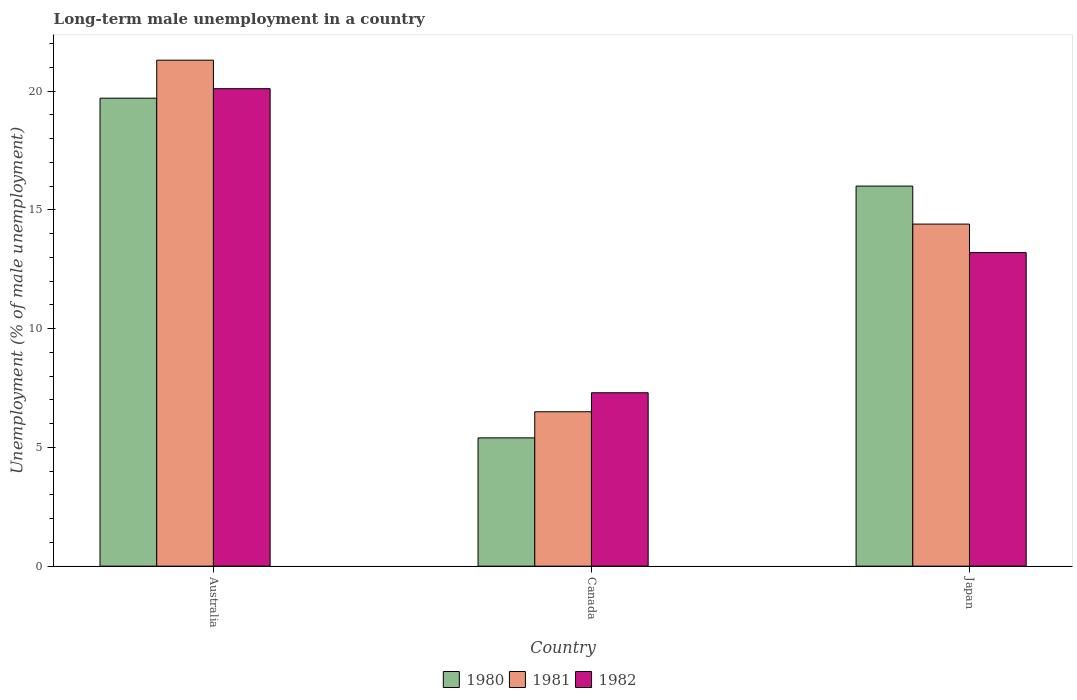How many different coloured bars are there?
Provide a short and direct response. 3. How many groups of bars are there?
Provide a succinct answer. 3. How many bars are there on the 2nd tick from the left?
Offer a very short reply. 3. In how many cases, is the number of bars for a given country not equal to the number of legend labels?
Give a very brief answer. 0. What is the percentage of long-term unemployed male population in 1982 in Canada?
Ensure brevity in your answer.  7.3. Across all countries, what is the maximum percentage of long-term unemployed male population in 1980?
Your response must be concise. 19.7. Across all countries, what is the minimum percentage of long-term unemployed male population in 1982?
Your answer should be compact. 7.3. In which country was the percentage of long-term unemployed male population in 1980 maximum?
Ensure brevity in your answer.  Australia. In which country was the percentage of long-term unemployed male population in 1982 minimum?
Your answer should be very brief. Canada. What is the total percentage of long-term unemployed male population in 1981 in the graph?
Your answer should be very brief. 42.2. What is the difference between the percentage of long-term unemployed male population in 1980 in Australia and that in Japan?
Provide a short and direct response. 3.7. What is the difference between the percentage of long-term unemployed male population in 1982 in Canada and the percentage of long-term unemployed male population in 1981 in Japan?
Give a very brief answer. -7.1. What is the average percentage of long-term unemployed male population in 1981 per country?
Make the answer very short. 14.07. What is the difference between the percentage of long-term unemployed male population of/in 1982 and percentage of long-term unemployed male population of/in 1980 in Australia?
Make the answer very short. 0.4. In how many countries, is the percentage of long-term unemployed male population in 1981 greater than 16 %?
Offer a terse response. 1. What is the ratio of the percentage of long-term unemployed male population in 1982 in Canada to that in Japan?
Offer a terse response. 0.55. Is the percentage of long-term unemployed male population in 1980 in Australia less than that in Japan?
Keep it short and to the point. No. Is the difference between the percentage of long-term unemployed male population in 1982 in Canada and Japan greater than the difference between the percentage of long-term unemployed male population in 1980 in Canada and Japan?
Keep it short and to the point. Yes. What is the difference between the highest and the second highest percentage of long-term unemployed male population in 1980?
Offer a terse response. -3.7. What is the difference between the highest and the lowest percentage of long-term unemployed male population in 1980?
Your answer should be compact. 14.3. In how many countries, is the percentage of long-term unemployed male population in 1980 greater than the average percentage of long-term unemployed male population in 1980 taken over all countries?
Provide a short and direct response. 2. What does the 1st bar from the left in Canada represents?
Your response must be concise. 1980. What is the difference between two consecutive major ticks on the Y-axis?
Offer a terse response. 5. Does the graph contain grids?
Keep it short and to the point. No. Where does the legend appear in the graph?
Offer a terse response. Bottom center. How are the legend labels stacked?
Offer a terse response. Horizontal. What is the title of the graph?
Offer a terse response. Long-term male unemployment in a country. What is the label or title of the X-axis?
Your answer should be compact. Country. What is the label or title of the Y-axis?
Provide a succinct answer. Unemployment (% of male unemployment). What is the Unemployment (% of male unemployment) of 1980 in Australia?
Offer a very short reply. 19.7. What is the Unemployment (% of male unemployment) of 1981 in Australia?
Offer a terse response. 21.3. What is the Unemployment (% of male unemployment) of 1982 in Australia?
Offer a very short reply. 20.1. What is the Unemployment (% of male unemployment) in 1980 in Canada?
Provide a succinct answer. 5.4. What is the Unemployment (% of male unemployment) of 1982 in Canada?
Your response must be concise. 7.3. What is the Unemployment (% of male unemployment) of 1980 in Japan?
Your answer should be very brief. 16. What is the Unemployment (% of male unemployment) of 1981 in Japan?
Your answer should be compact. 14.4. What is the Unemployment (% of male unemployment) in 1982 in Japan?
Make the answer very short. 13.2. Across all countries, what is the maximum Unemployment (% of male unemployment) in 1980?
Provide a succinct answer. 19.7. Across all countries, what is the maximum Unemployment (% of male unemployment) of 1981?
Provide a short and direct response. 21.3. Across all countries, what is the maximum Unemployment (% of male unemployment) in 1982?
Offer a very short reply. 20.1. Across all countries, what is the minimum Unemployment (% of male unemployment) in 1980?
Offer a terse response. 5.4. Across all countries, what is the minimum Unemployment (% of male unemployment) of 1982?
Give a very brief answer. 7.3. What is the total Unemployment (% of male unemployment) of 1980 in the graph?
Offer a terse response. 41.1. What is the total Unemployment (% of male unemployment) of 1981 in the graph?
Offer a very short reply. 42.2. What is the total Unemployment (% of male unemployment) of 1982 in the graph?
Offer a very short reply. 40.6. What is the difference between the Unemployment (% of male unemployment) of 1980 in Australia and that in Canada?
Provide a succinct answer. 14.3. What is the difference between the Unemployment (% of male unemployment) in 1981 in Australia and that in Canada?
Your response must be concise. 14.8. What is the difference between the Unemployment (% of male unemployment) of 1981 in Australia and the Unemployment (% of male unemployment) of 1982 in Canada?
Your answer should be very brief. 14. What is the difference between the Unemployment (% of male unemployment) of 1981 in Australia and the Unemployment (% of male unemployment) of 1982 in Japan?
Provide a succinct answer. 8.1. What is the difference between the Unemployment (% of male unemployment) of 1980 in Canada and the Unemployment (% of male unemployment) of 1982 in Japan?
Ensure brevity in your answer.  -7.8. What is the difference between the Unemployment (% of male unemployment) of 1981 in Canada and the Unemployment (% of male unemployment) of 1982 in Japan?
Your response must be concise. -6.7. What is the average Unemployment (% of male unemployment) in 1981 per country?
Your answer should be compact. 14.07. What is the average Unemployment (% of male unemployment) of 1982 per country?
Ensure brevity in your answer.  13.53. What is the difference between the Unemployment (% of male unemployment) of 1980 and Unemployment (% of male unemployment) of 1982 in Australia?
Offer a very short reply. -0.4. What is the difference between the Unemployment (% of male unemployment) in 1981 and Unemployment (% of male unemployment) in 1982 in Australia?
Provide a succinct answer. 1.2. What is the difference between the Unemployment (% of male unemployment) in 1980 and Unemployment (% of male unemployment) in 1982 in Japan?
Keep it short and to the point. 2.8. What is the difference between the Unemployment (% of male unemployment) in 1981 and Unemployment (% of male unemployment) in 1982 in Japan?
Provide a short and direct response. 1.2. What is the ratio of the Unemployment (% of male unemployment) of 1980 in Australia to that in Canada?
Give a very brief answer. 3.65. What is the ratio of the Unemployment (% of male unemployment) of 1981 in Australia to that in Canada?
Your answer should be compact. 3.28. What is the ratio of the Unemployment (% of male unemployment) in 1982 in Australia to that in Canada?
Keep it short and to the point. 2.75. What is the ratio of the Unemployment (% of male unemployment) in 1980 in Australia to that in Japan?
Offer a very short reply. 1.23. What is the ratio of the Unemployment (% of male unemployment) in 1981 in Australia to that in Japan?
Provide a short and direct response. 1.48. What is the ratio of the Unemployment (% of male unemployment) of 1982 in Australia to that in Japan?
Ensure brevity in your answer.  1.52. What is the ratio of the Unemployment (% of male unemployment) of 1980 in Canada to that in Japan?
Keep it short and to the point. 0.34. What is the ratio of the Unemployment (% of male unemployment) of 1981 in Canada to that in Japan?
Provide a succinct answer. 0.45. What is the ratio of the Unemployment (% of male unemployment) of 1982 in Canada to that in Japan?
Your answer should be compact. 0.55. What is the difference between the highest and the second highest Unemployment (% of male unemployment) of 1980?
Provide a short and direct response. 3.7. What is the difference between the highest and the second highest Unemployment (% of male unemployment) in 1981?
Ensure brevity in your answer.  6.9. What is the difference between the highest and the lowest Unemployment (% of male unemployment) in 1980?
Provide a succinct answer. 14.3. What is the difference between the highest and the lowest Unemployment (% of male unemployment) in 1981?
Ensure brevity in your answer.  14.8. 